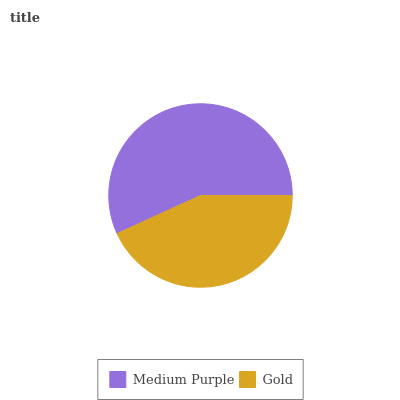Is Gold the minimum?
Answer yes or no. Yes. Is Medium Purple the maximum?
Answer yes or no. Yes. Is Gold the maximum?
Answer yes or no. No. Is Medium Purple greater than Gold?
Answer yes or no. Yes. Is Gold less than Medium Purple?
Answer yes or no. Yes. Is Gold greater than Medium Purple?
Answer yes or no. No. Is Medium Purple less than Gold?
Answer yes or no. No. Is Medium Purple the high median?
Answer yes or no. Yes. Is Gold the low median?
Answer yes or no. Yes. Is Gold the high median?
Answer yes or no. No. Is Medium Purple the low median?
Answer yes or no. No. 